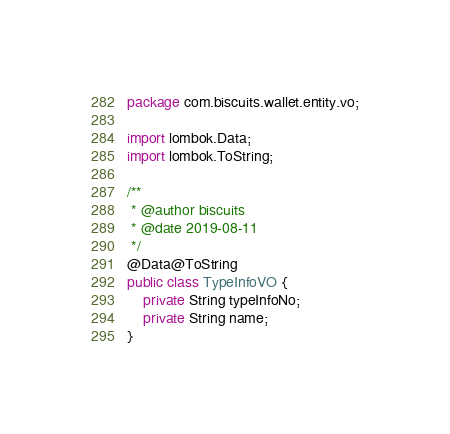Convert code to text. <code><loc_0><loc_0><loc_500><loc_500><_Java_>package com.biscuits.wallet.entity.vo;

import lombok.Data;
import lombok.ToString;

/**
 * @author biscuits
 * @date 2019-08-11
 */
@Data@ToString
public class TypeInfoVO {
    private String typeInfoNo;
    private String name;
}
</code> 